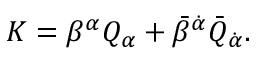Convert formula to latex. <formula><loc_0><loc_0><loc_500><loc_500>K = \beta ^ { \alpha } Q _ { \alpha } + \bar { \beta } ^ { \dot { \alpha } } \bar { Q } _ { \dot { \alpha } } .</formula> 